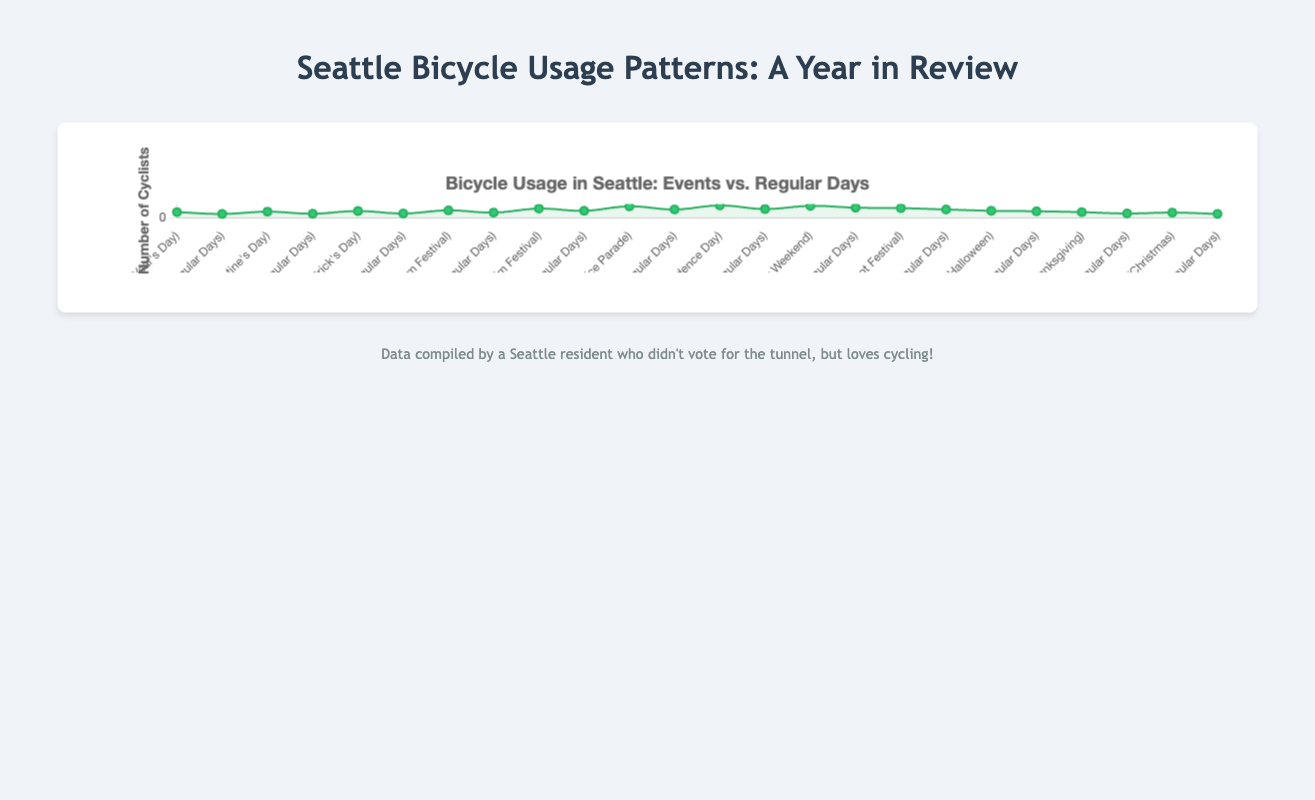Which month had the highest bicycle usage on a special event? According to the figure, July during Independence Day recorded the highest bicycle usage.
Answer: July Which month saw the smallest difference in bicycle usage between regular days and a special event? In January, the bicycle usage during New Year's Day was 1200, and 800 on regular days. The difference is 400, which is the smallest among all months.
Answer: January What is the total bicycle usage for special events in June and July combined? Bicycle usage for Fremont Solstice Parade in June is 2500, and for Independence Day in July is 2700. Summing them up gives 2500 + 2700 = 5200.
Answer: 5200 Compare the average bicycle usage on special events and regular days across the entire year. Which one is higher? Special Events: (1200 + 1300 + 1450 + 1600 + 2000 + 2500 + 2700 + 2600 + 2100 + 1500 + 1200 + 1100) / 12 = 1860. Regular Days: (800 + 850 + 900 + 1100 + 1500 + 1800 + 1900 + 2200 + 1800 + 1400 + 900 + 800) / 12 = 1391.7. Hence, the average for special events is higher.
Answer: Special Events How much higher was the bicycle usage during Seafair Weekend compared to regular days in August? The bicycle usage during Seafair Weekend was 2600, and on regular days in August was 2200. The difference is 2600 - 2200 = 400.
Answer: 400 During which event did bicycle usage exceed 2000 for the first time in the year? Fremont Solstice Parade in June had 2500 bicycle users, which is the first instance in the year exceeding 2000.
Answer: Fremont Solstice Parade What's the increase in bicycle usage from regular days to special event days in May? The bicycle usage on regular days in May is 1500, and during the Seattle International Film Festival, it is 2000. The increase is 2000 - 1500 = 500.
Answer: 500 Identify two consecutive months where the total bicycle usage (both special events and regular days) is at its peak. What are these months and what is the total usage? For June: 2500 (Event) + 1800 (Regular) = 4300, and for July: 2700 (Event) + 1900 (Regular) = 4600. The total for these months is 4300 + 4600 = 8900.
Answer: June and July, 8900 Which special event in the second half of the year shows the maximum bicycle usage? Independence Day in July has the maximum bicycle usage of 2700 in the latter half of the year.
Answer: Independence Day 